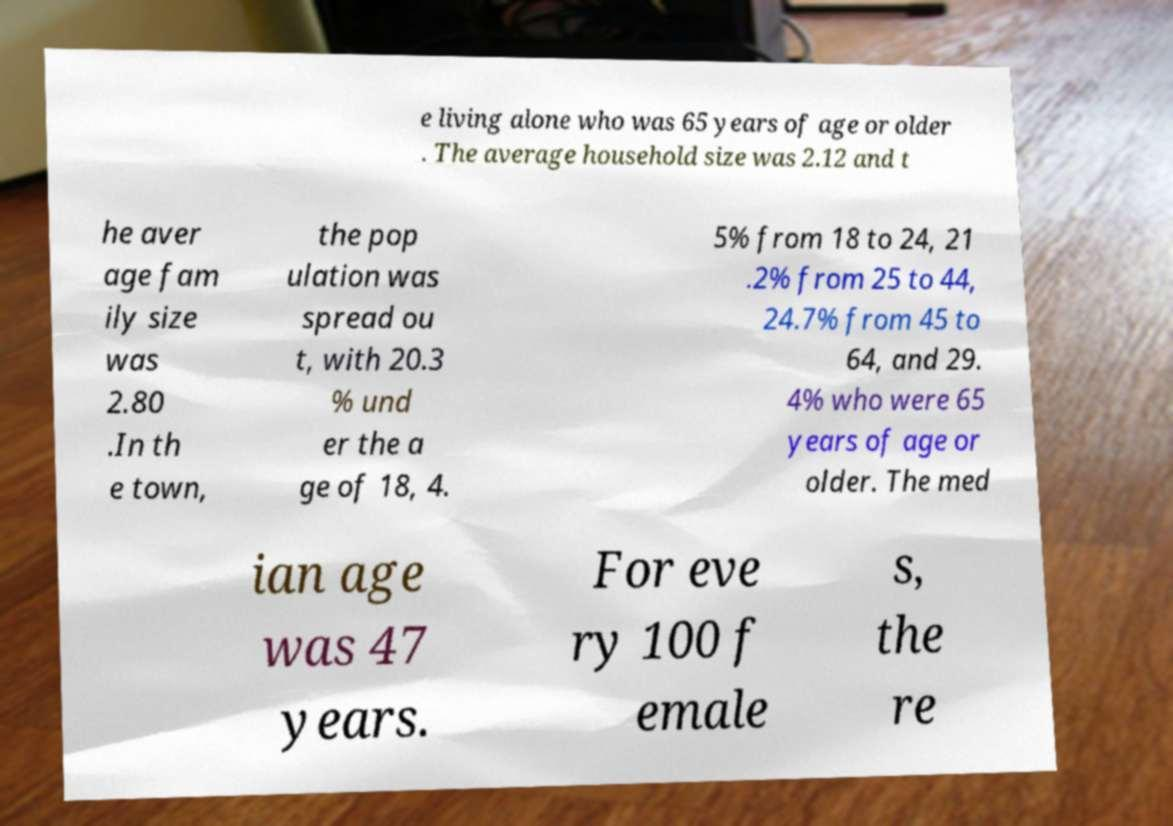Please identify and transcribe the text found in this image. e living alone who was 65 years of age or older . The average household size was 2.12 and t he aver age fam ily size was 2.80 .In th e town, the pop ulation was spread ou t, with 20.3 % und er the a ge of 18, 4. 5% from 18 to 24, 21 .2% from 25 to 44, 24.7% from 45 to 64, and 29. 4% who were 65 years of age or older. The med ian age was 47 years. For eve ry 100 f emale s, the re 